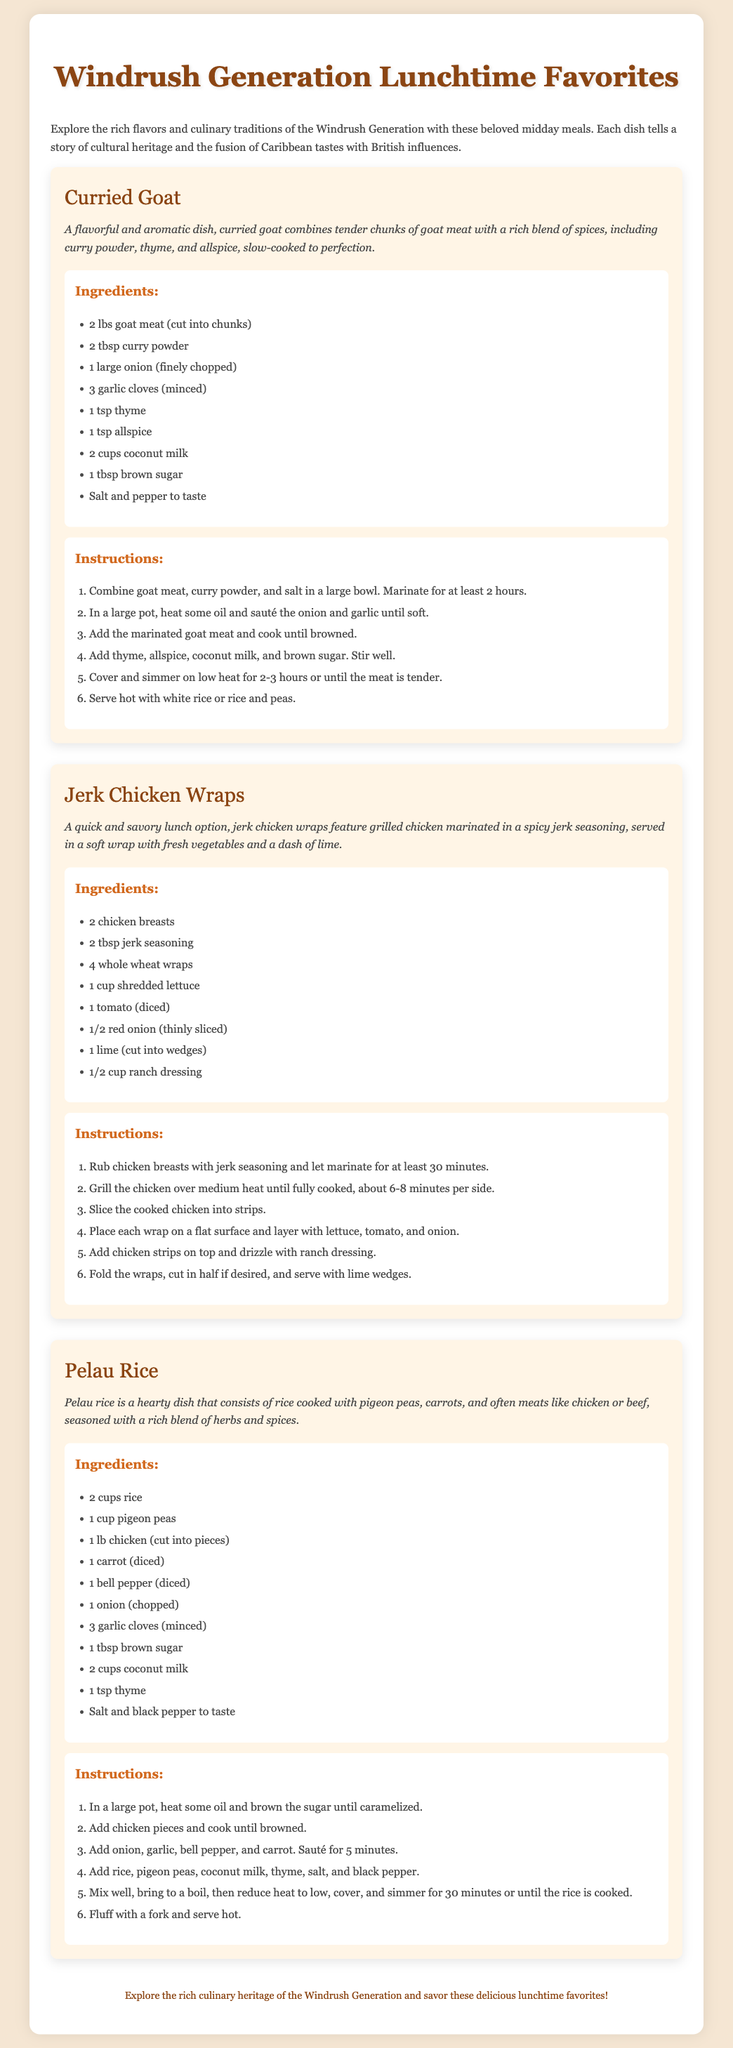What is the first dish listed? The first dish listed in the document is curried goat.
Answer: curried goat How many wraps are mentioned in the jerk chicken wrap recipe? The recipe mentions 4 whole wheat wraps as part of the ingredients.
Answer: 4 What is the main ingredient in pelau rice? The main ingredients in pelau rice are rice and pigeon peas.
Answer: rice and pigeon peas How long should the goat meat marinate? The recipe instructs to marinate the goat meat for at least 2 hours.
Answer: 2 hours What is the cooking time for the jerk chicken? The cooking time for the jerk chicken is about 6-8 minutes per side.
Answer: 6-8 minutes per side What type of milk is used in curried goat? The curried goat recipe uses coconut milk.
Answer: coconut milk Which ingredient adds sweetness to the curried goat? Brown sugar is the ingredient that adds sweetness to the curried goat.
Answer: brown sugar What dish combines rice with pigeon peas and vegetables? The dish that combines rice with pigeon peas and vegetables is pelau rice.
Answer: pelau rice 